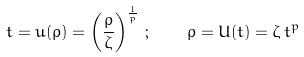<formula> <loc_0><loc_0><loc_500><loc_500>t = u ( \rho ) = \left ( \frac { \rho } { \zeta } \right ) ^ { \frac { 1 } { p } } \, ; \quad \rho = U ( t ) = \zeta \, t ^ { p }</formula> 